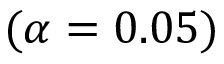<formula> <loc_0><loc_0><loc_500><loc_500>( \alpha = 0 . 0 5 )</formula> 